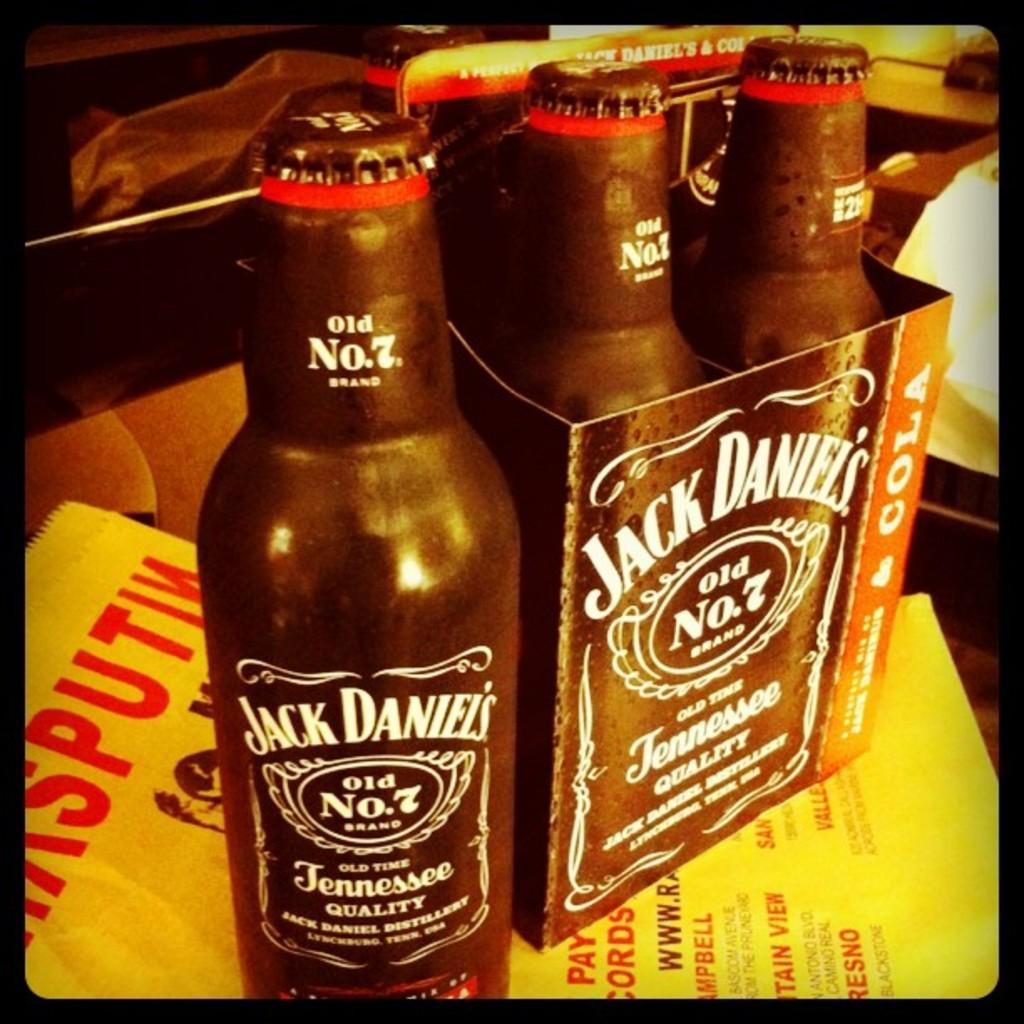Provide a one-sentence caption for the provided image. A pack of Jack Daniel's old number 7 sits on a table. 